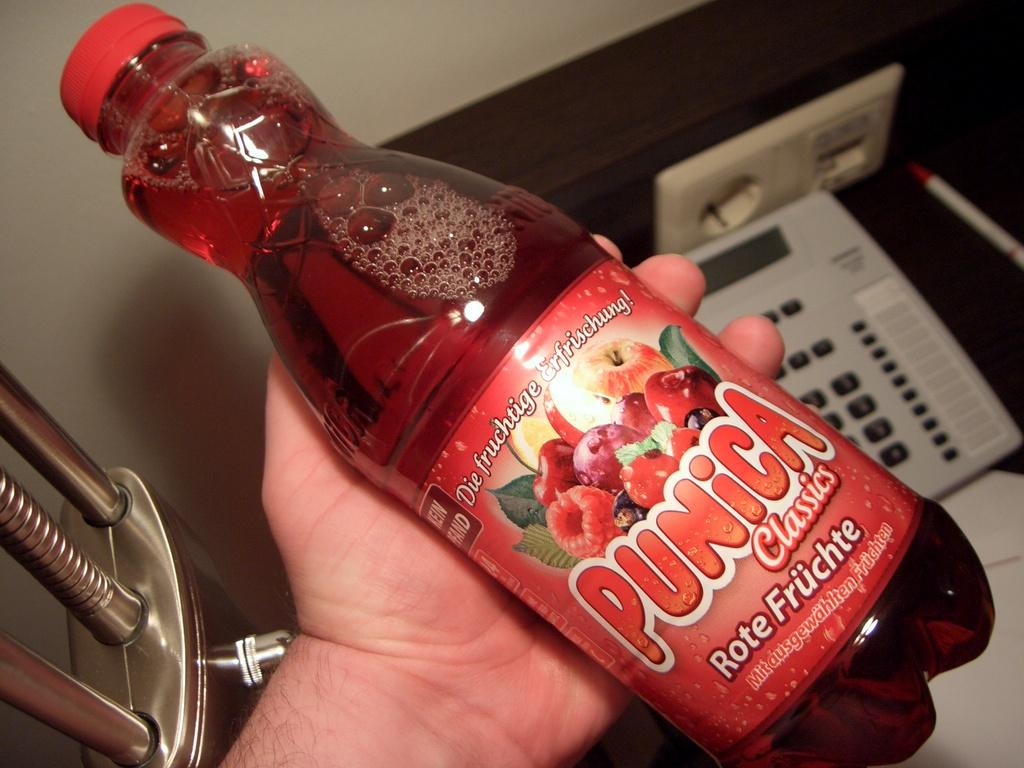<image>
Relay a brief, clear account of the picture shown. A bottle of a red liquid has Punica Classics on it. 